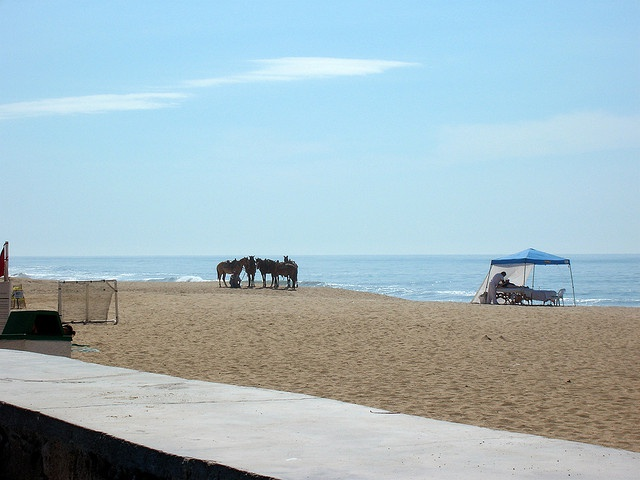Describe the objects in this image and their specific colors. I can see horse in lightblue, black, gray, and darkgray tones, horse in lightblue, black, and gray tones, people in lightblue, gray, black, and darkgray tones, horse in lightblue, black, gray, darkgray, and purple tones, and chair in lightblue, gray, and darkgray tones in this image. 